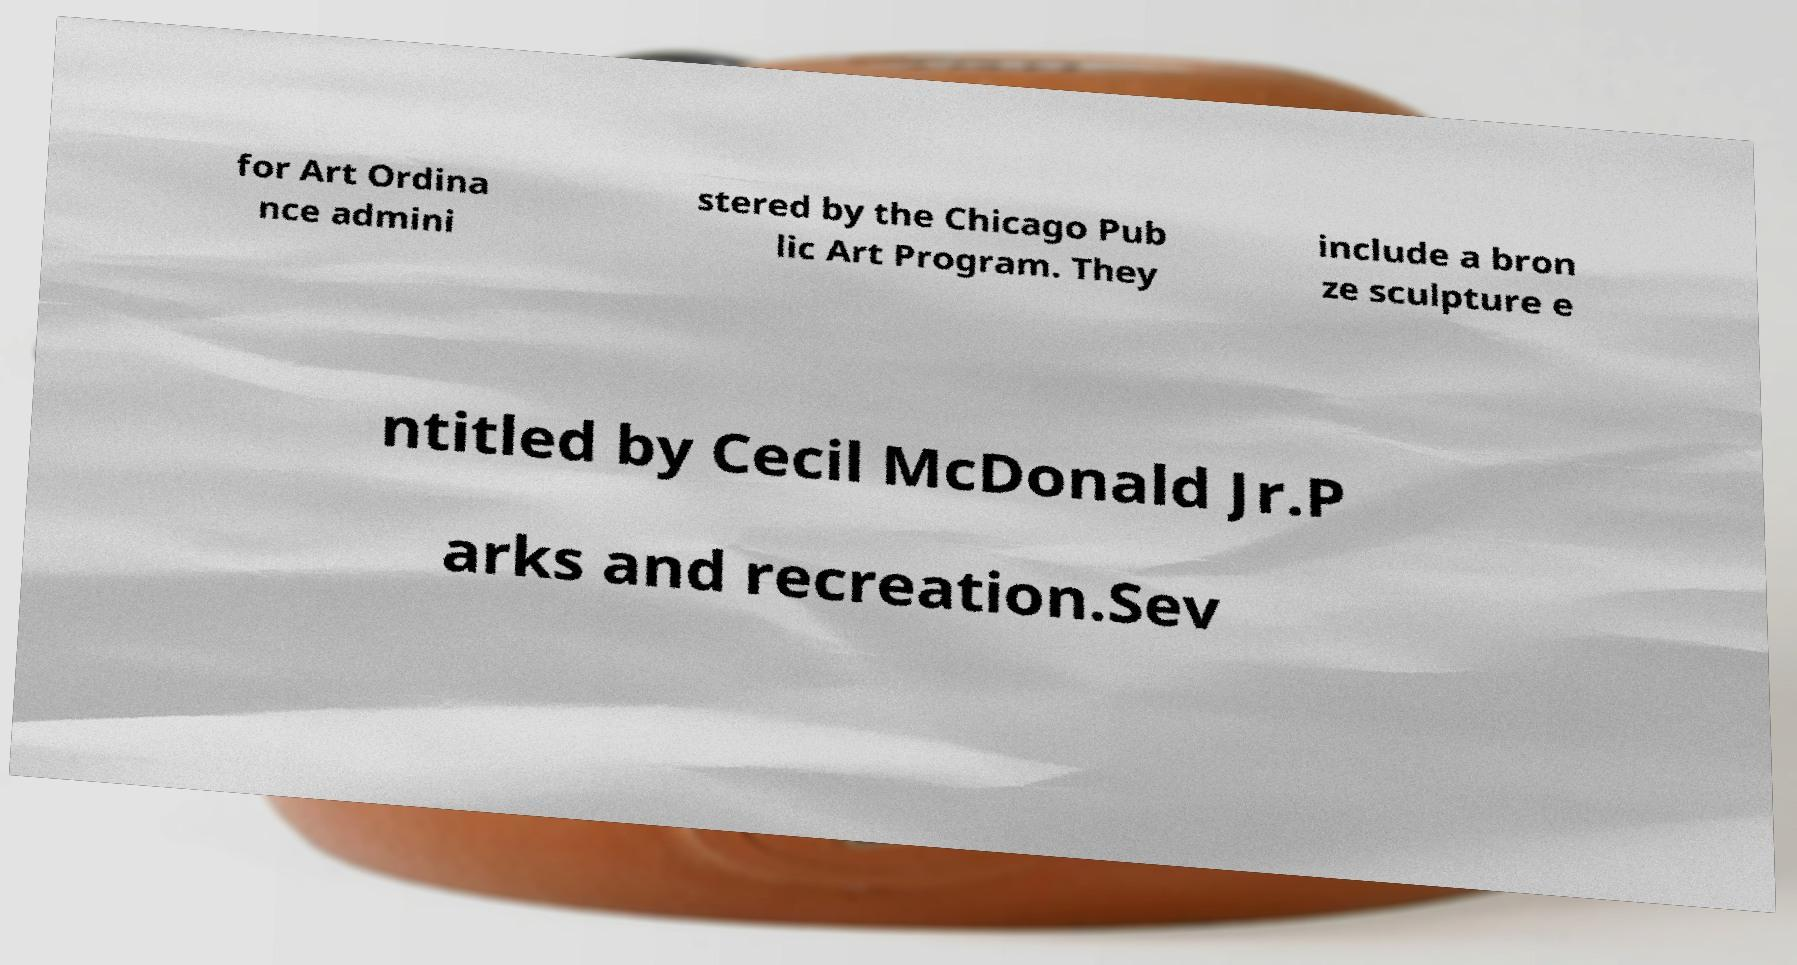I need the written content from this picture converted into text. Can you do that? for Art Ordina nce admini stered by the Chicago Pub lic Art Program. They include a bron ze sculpture e ntitled by Cecil McDonald Jr.P arks and recreation.Sev 